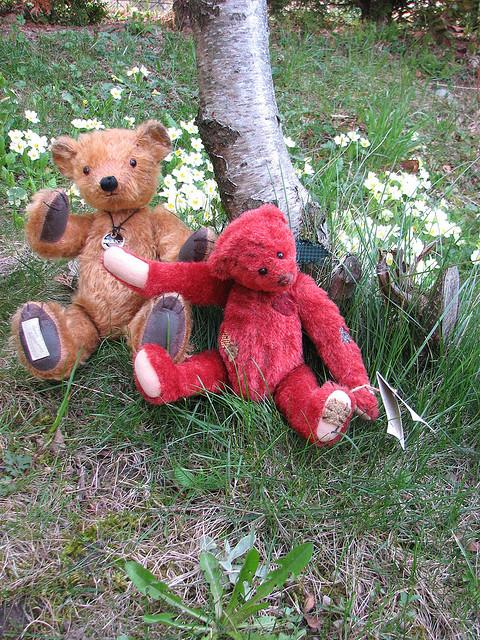Are there flowers in the image?
Write a very short answer. Yes. Are the toys made by different companies?
Quick response, please. Yes. How many toys are here?
Give a very brief answer. 2. 